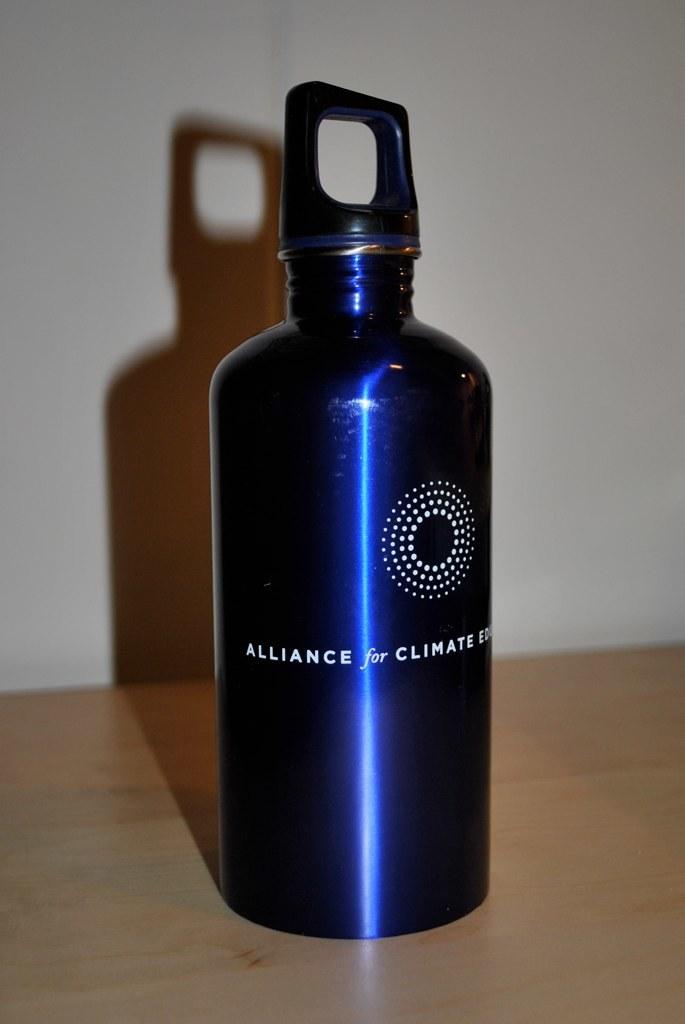What is the third word?
Offer a very short reply. Climate. What is the first word on the left of this bottle?
Keep it short and to the point. Alliance. 